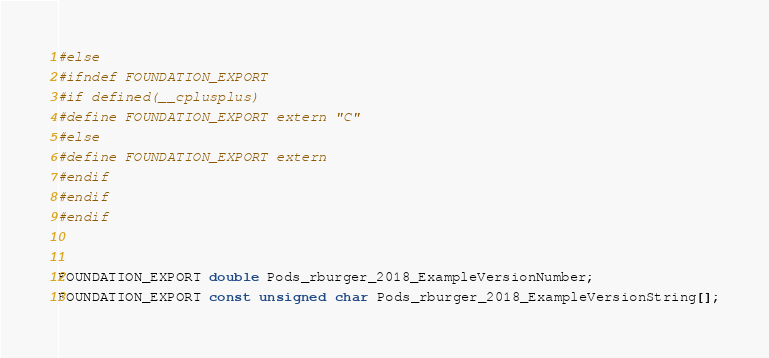<code> <loc_0><loc_0><loc_500><loc_500><_C_>#else
#ifndef FOUNDATION_EXPORT
#if defined(__cplusplus)
#define FOUNDATION_EXPORT extern "C"
#else
#define FOUNDATION_EXPORT extern
#endif
#endif
#endif


FOUNDATION_EXPORT double Pods_rburger_2018_ExampleVersionNumber;
FOUNDATION_EXPORT const unsigned char Pods_rburger_2018_ExampleVersionString[];

</code> 